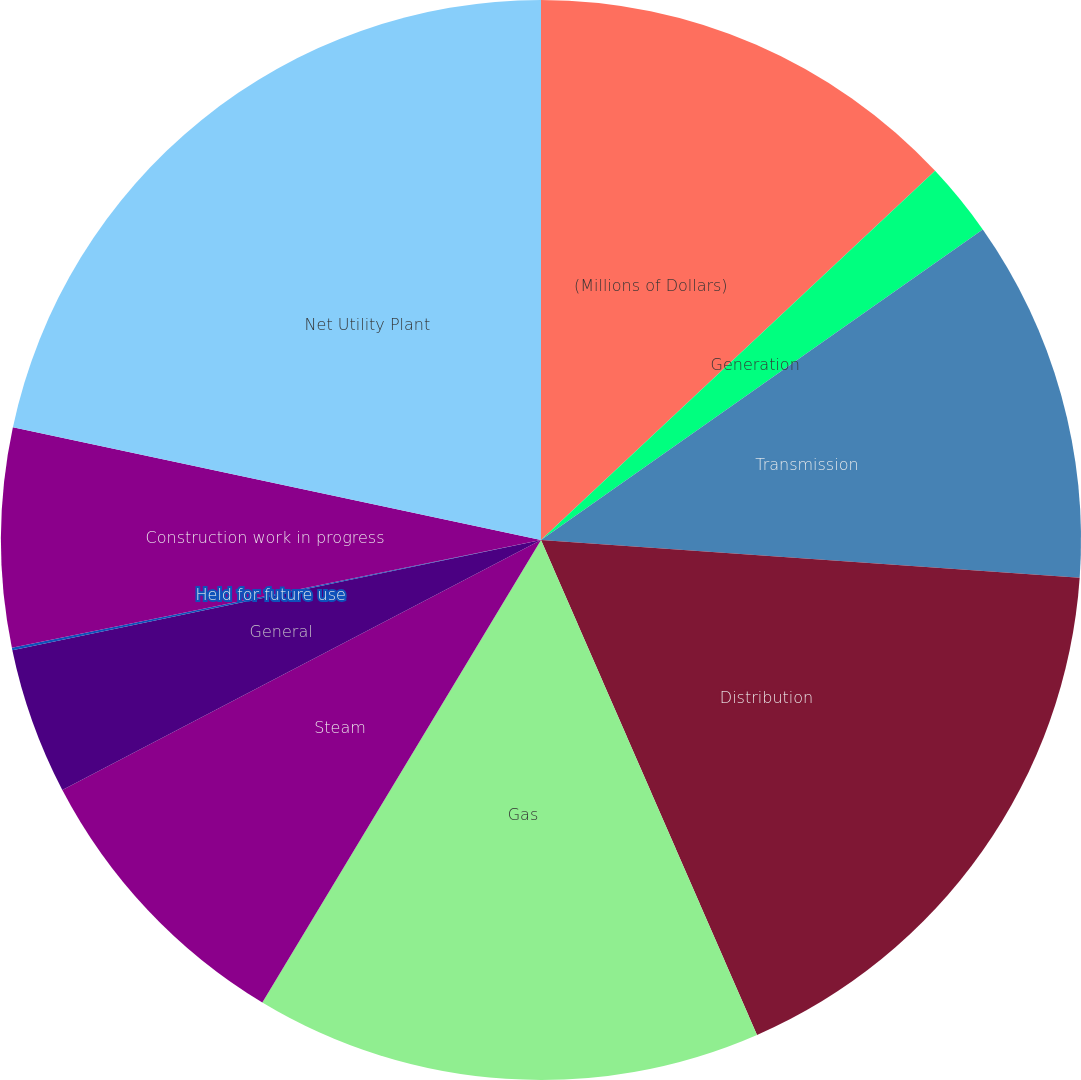Convert chart to OTSL. <chart><loc_0><loc_0><loc_500><loc_500><pie_chart><fcel>(Millions of Dollars)<fcel>Generation<fcel>Transmission<fcel>Distribution<fcel>Gas<fcel>Steam<fcel>General<fcel>Held for future use<fcel>Construction work in progress<fcel>Net Utility Plant<nl><fcel>13.02%<fcel>2.23%<fcel>10.86%<fcel>17.34%<fcel>15.18%<fcel>8.71%<fcel>4.39%<fcel>0.07%<fcel>6.55%<fcel>21.65%<nl></chart> 